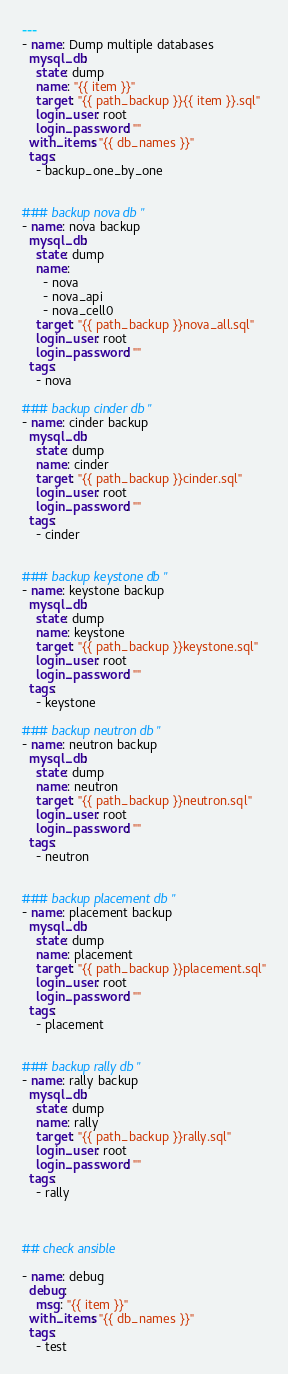Convert code to text. <code><loc_0><loc_0><loc_500><loc_500><_YAML_>---
- name: Dump multiple databases
  mysql_db:
    state: dump
    name: "{{ item }}"  
    target: "{{ path_backup }}{{ item }}.sql"
    login_user: root
    login_password: ""
  with_items: "{{ db_names }}"
  tags:
    - backup_one_by_one


### backup nova db "
- name: nova backup
  mysql_db:
    state: dump
    name:
      - nova
      - nova_api
      - nova_cell0
    target: "{{ path_backup }}nova_all.sql"
    login_user: root
    login_password: ""
  tags:
    - nova

### backup cinder db "
- name: cinder backup
  mysql_db:
    state: dump
    name: cinder
    target: "{{ path_backup }}cinder.sql"
    login_user: root
    login_password: ""
  tags:
    - cinder


### backup keystone db "
- name: keystone backup
  mysql_db:
    state: dump
    name: keystone
    target: "{{ path_backup }}keystone.sql"
    login_user: root
    login_password: ""
  tags:
    - keystone

### backup neutron db "
- name: neutron backup
  mysql_db:
    state: dump
    name: neutron
    target: "{{ path_backup }}neutron.sql"
    login_user: root
    login_password: ""
  tags:
    - neutron


### backup placement db "
- name: placement backup
  mysql_db:
    state: dump
    name: placement
    target: "{{ path_backup }}placement.sql"
    login_user: root
    login_password: ""
  tags:
    - placement 


### backup rally db "
- name: rally backup
  mysql_db:
    state: dump
    name: rally
    target: "{{ path_backup }}rally.sql"
    login_user: root
    login_password: ""
  tags:
    - rally 



## check ansible

- name: debug
  debug:
    msg: "{{ item }}"
  with_items: "{{ db_names }}"
  tags:
    - test
</code> 